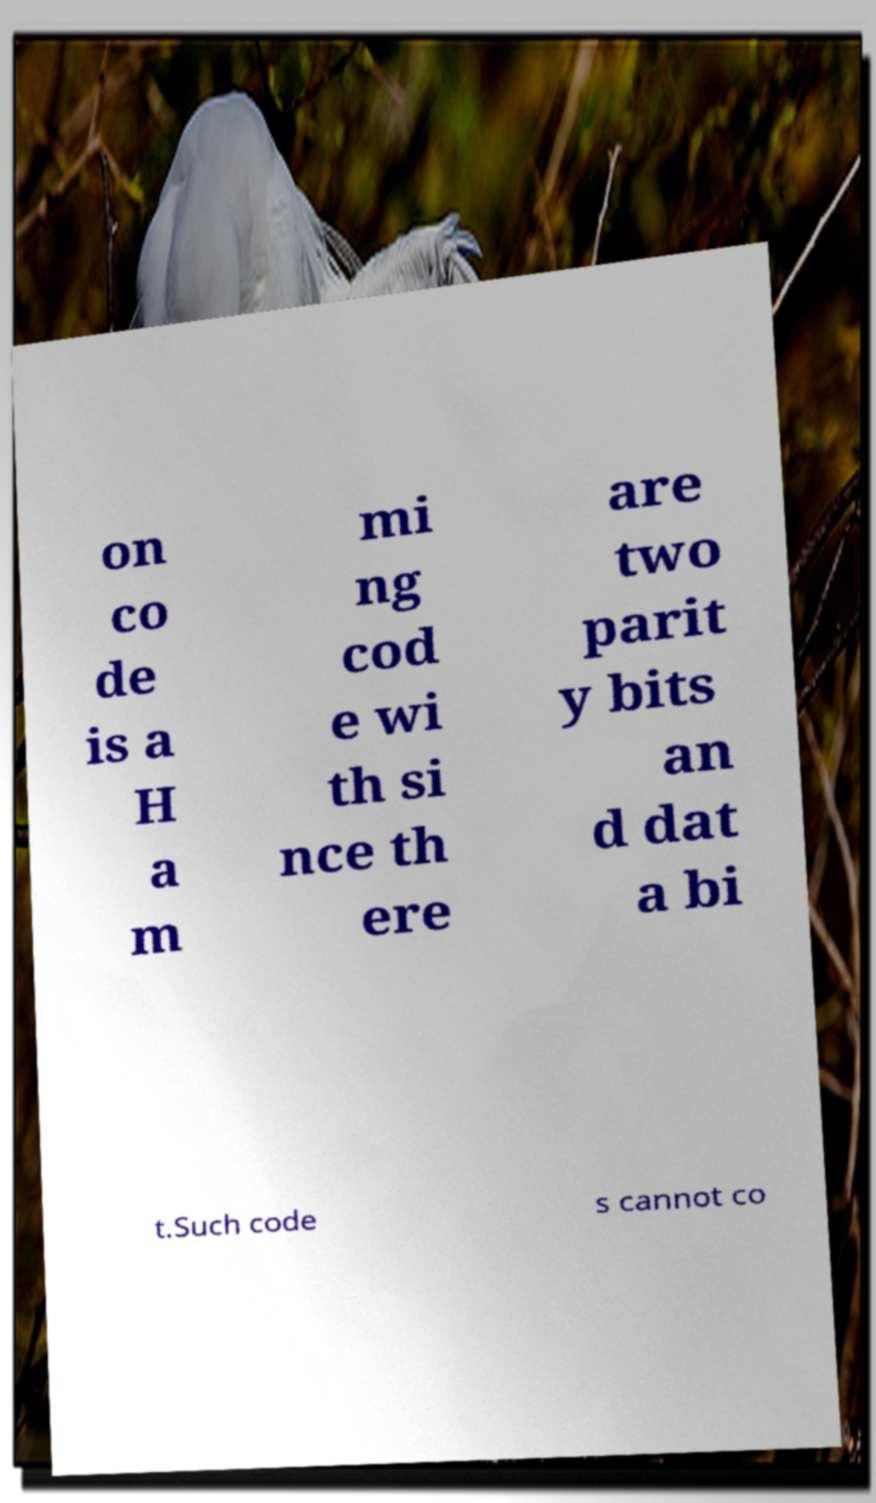Could you assist in decoding the text presented in this image and type it out clearly? on co de is a H a m mi ng cod e wi th si nce th ere are two parit y bits an d dat a bi t.Such code s cannot co 